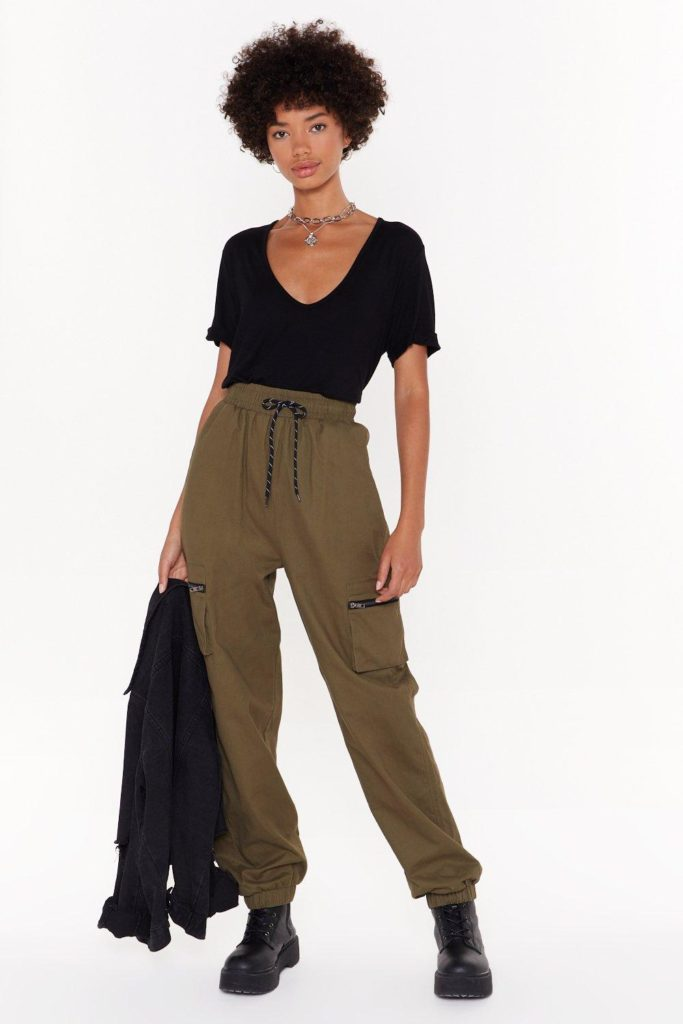What kind of mood or atmosphere does this photograph create? The bright and clean lighting combined with the minimalist background creates a modern and sleek mood. The individual's confident stance and neutral facial expression convey a sense of calm and poise. The earthy tones of the olive green cargo pants and the stark contrast with the black t-shirt and boots present a balance between ruggedness and simplicity. Overall, the image evokes a contemporary and stylish atmosphere. 